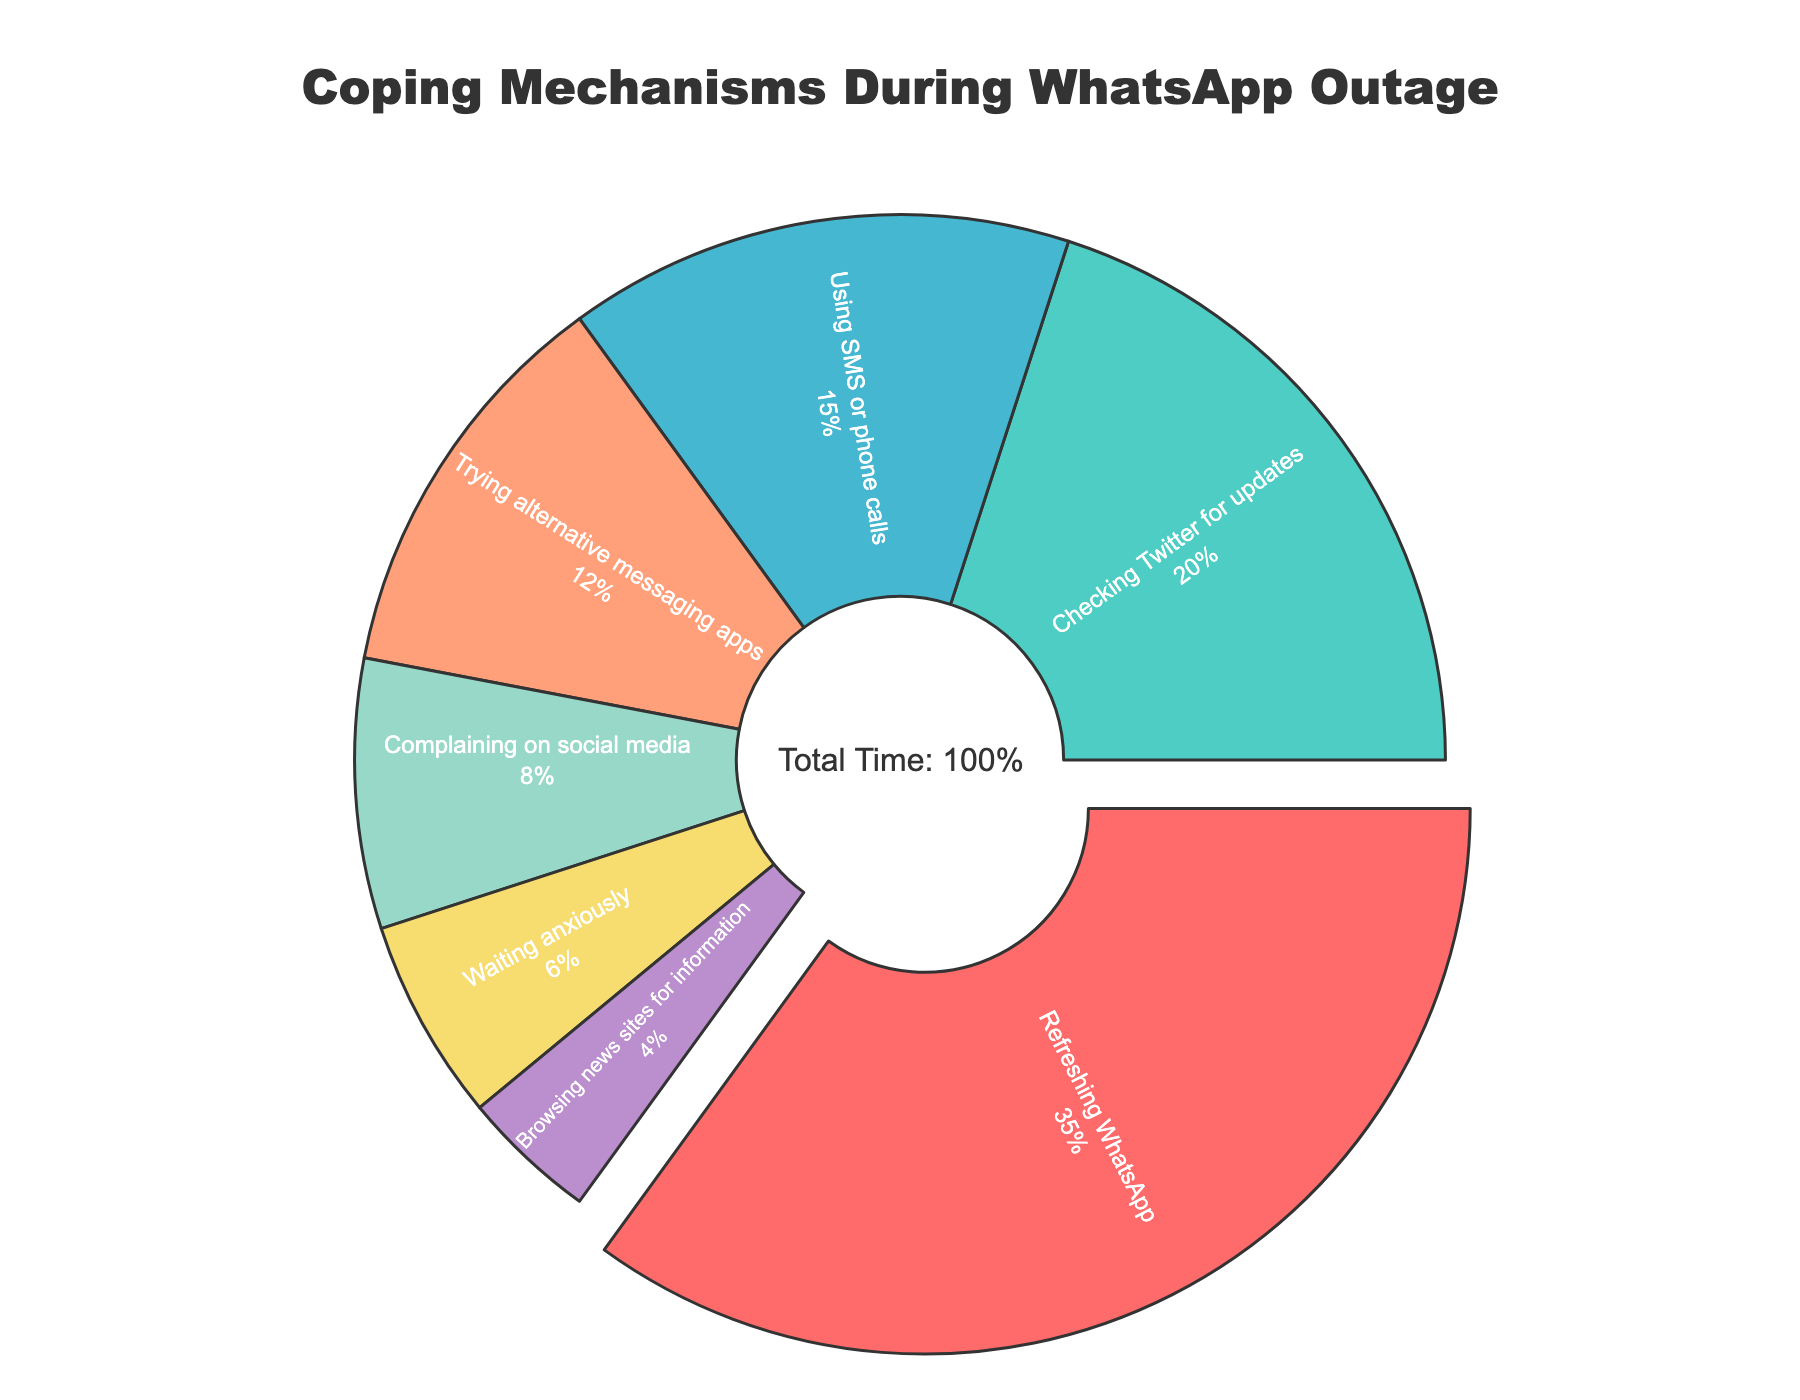What percentage of time was spent refreshing WhatsApp? We can directly read the percentage from the pie chart, which is labeled "Refreshing WhatsApp."
Answer: 35% What activities combined account for more than half of the time spent during the outage? Adding the percentages for the most significant segments: Refreshing WhatsApp (35%) + Checking Twitter for updates (20%) = 55%. This is more than half of the total time.
Answer: Refreshing WhatsApp and Checking Twitter for updates Which activity took the least amount of time? We can see that the smallest slice of the pie chart, labeled "Browsing news sites for information," has the smallest percentage.
Answer: Browsing news sites for information How much greater is the time spent refreshing WhatsApp compared to waiting anxiously? The time spent on refreshing WhatsApp is 35%, and waiting anxiously is 6%. Subtracting these two gives 35% - 6% = 29%.
Answer: 29% Which activities individually took less than 10% of the total time? We look for segments with less than 10%: Complaining on social media (8%), Waiting anxiously (6%), Browsing news sites for information (4%).
Answer: Complaining on social media, Waiting anxiously, Browsing news sites for information What is the combined percentage of time spent using SMS/phone calls and trying alternative messaging apps? Adding the percentages for using SMS/phone calls (15%) and trying alternative messaging apps (12%): 15% + 12% = 27%.
Answer: 27% How does the time spent on using SMS or phone calls compare to checking Twitter for updates? We compare the two percentages: Checking Twitter for updates is 20%, and using SMS/phone calls is 15%. Checking Twitter for updates is greater than using SMS/phone calls by 5%.
Answer: Checking Twitter for updates is greater by 5% What activities accounted for exactly 20% or more of the time? We identify the slices with 20% or more: Refreshing WhatsApp (35%) and Checking Twitter for updates (20%).
Answer: Refreshing WhatsApp and Checking Twitter for updates What fraction of the total time was spent complaining on social media? The percentage for complaining on social media is 8%, and 8% out of 100% can be written as 8/100 or 2/25.
Answer: 2/25 